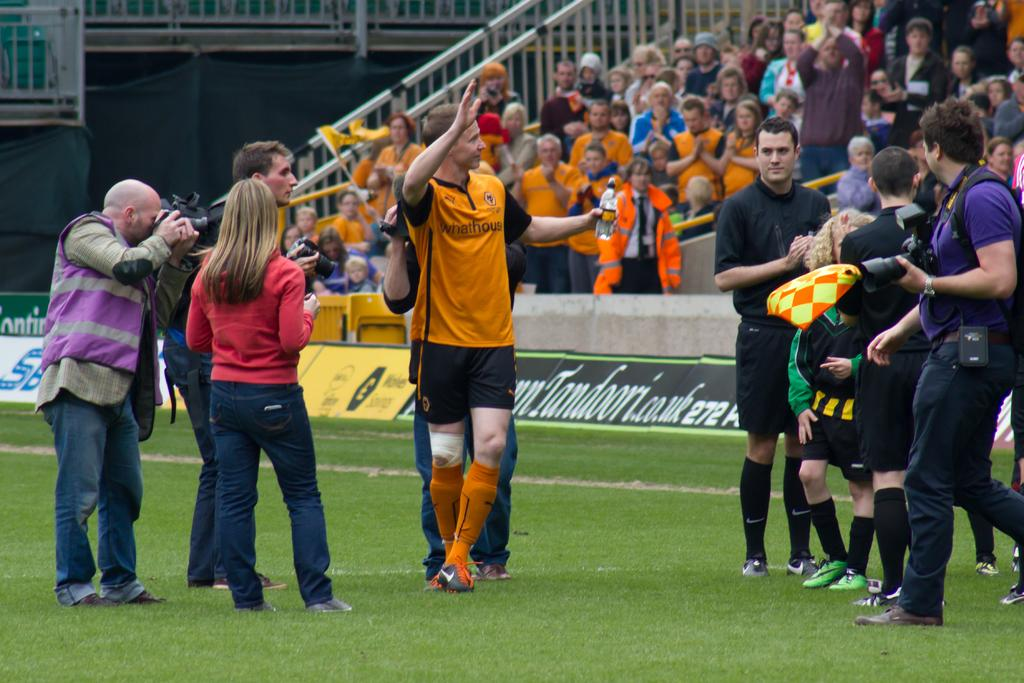What are the people in the image doing? The people in the image are standing, and some of them are holding cameras. What can be seen in the background of the image? There is a crowd sitting in the background of the image, as well as railings. What type of surface is at the bottom of the image? There is grass at the bottom of the image. Can you see any cobwebs in the image? There are no cobwebs visible in the image. What type of sport is being played in the image? There is no sport being played in the image; it primarily features people standing and holding cameras. 